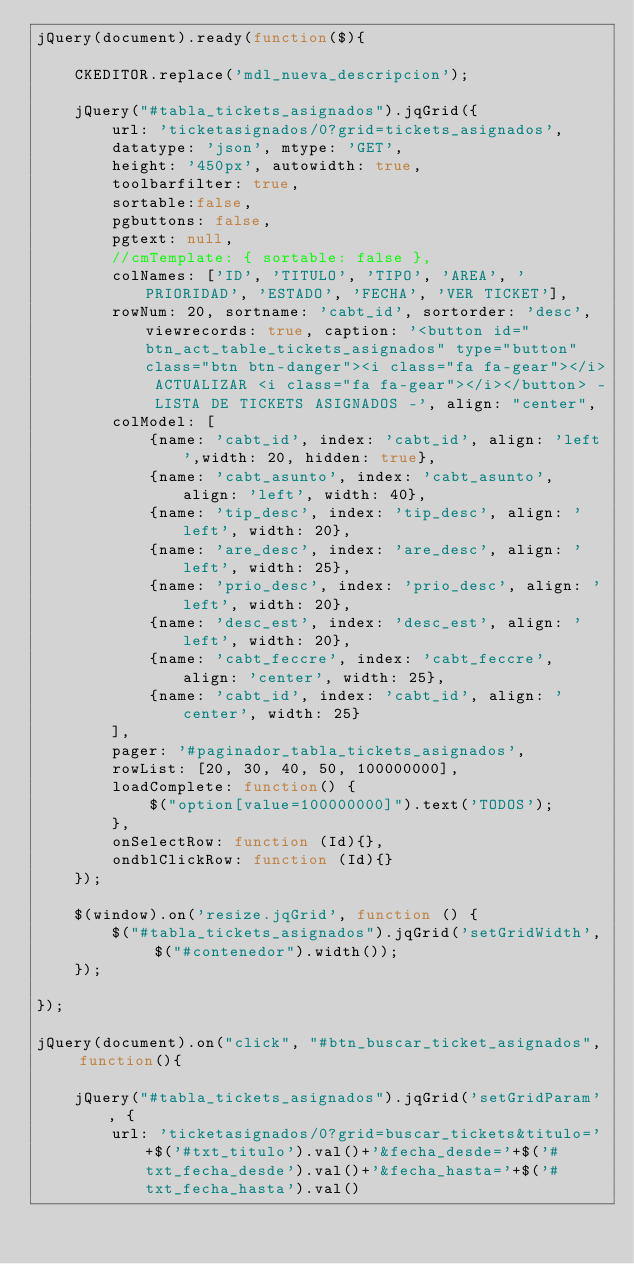<code> <loc_0><loc_0><loc_500><loc_500><_JavaScript_>jQuery(document).ready(function($){
    
    CKEDITOR.replace('mdl_nueva_descripcion');
    
    jQuery("#tabla_tickets_asignados").jqGrid({
        url: 'ticketasignados/0?grid=tickets_asignados',
        datatype: 'json', mtype: 'GET',
        height: '450px', autowidth: true,
        toolbarfilter: true,
        sortable:false,
        pgbuttons: false,
        pgtext: null, 
        //cmTemplate: { sortable: false },
        colNames: ['ID', 'TITULO', 'TIPO', 'AREA', 'PRIORIDAD', 'ESTADO', 'FECHA', 'VER TICKET'],
        rowNum: 20, sortname: 'cabt_id', sortorder: 'desc', viewrecords: true, caption: '<button id="btn_act_table_tickets_asignados" type="button" class="btn btn-danger"><i class="fa fa-gear"></i> ACTUALIZAR <i class="fa fa-gear"></i></button> - LISTA DE TICKETS ASIGNADOS -', align: "center",
        colModel: [
            {name: 'cabt_id', index: 'cabt_id', align: 'left',width: 20, hidden: true},
            {name: 'cabt_asunto', index: 'cabt_asunto', align: 'left', width: 40},
            {name: 'tip_desc', index: 'tip_desc', align: 'left', width: 20},
            {name: 'are_desc', index: 'are_desc', align: 'left', width: 25},
            {name: 'prio_desc', index: 'prio_desc', align: 'left', width: 20},
            {name: 'desc_est', index: 'desc_est', align: 'left', width: 20},
            {name: 'cabt_feccre', index: 'cabt_feccre', align: 'center', width: 25},
            {name: 'cabt_id', index: 'cabt_id', align: 'center', width: 25}
        ],
        pager: '#paginador_tabla_tickets_asignados',
        rowList: [20, 30, 40, 50, 100000000],
        loadComplete: function() {
            $("option[value=100000000]").text('TODOS');
        },
        onSelectRow: function (Id){},
        ondblClickRow: function (Id){}
    });
    
    $(window).on('resize.jqGrid', function () {
        $("#tabla_tickets_asignados").jqGrid('setGridWidth', $("#contenedor").width());
    });
    
});

jQuery(document).on("click", "#btn_buscar_ticket_asignados", function(){

    jQuery("#tabla_tickets_asignados").jqGrid('setGridParam', {
        url: 'ticketasignados/0?grid=buscar_tickets&titulo='+$('#txt_titulo').val()+'&fecha_desde='+$('#txt_fecha_desde').val()+'&fecha_hasta='+$('#txt_fecha_hasta').val()</code> 